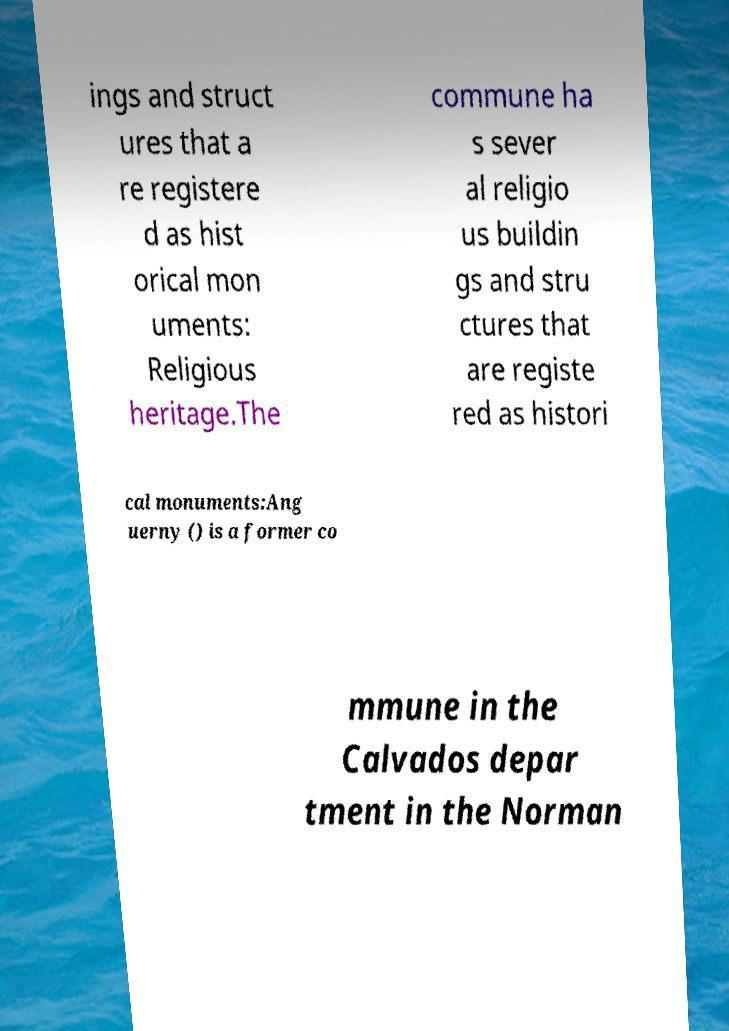Could you assist in decoding the text presented in this image and type it out clearly? ings and struct ures that a re registere d as hist orical mon uments: Religious heritage.The commune ha s sever al religio us buildin gs and stru ctures that are registe red as histori cal monuments:Ang uerny () is a former co mmune in the Calvados depar tment in the Norman 